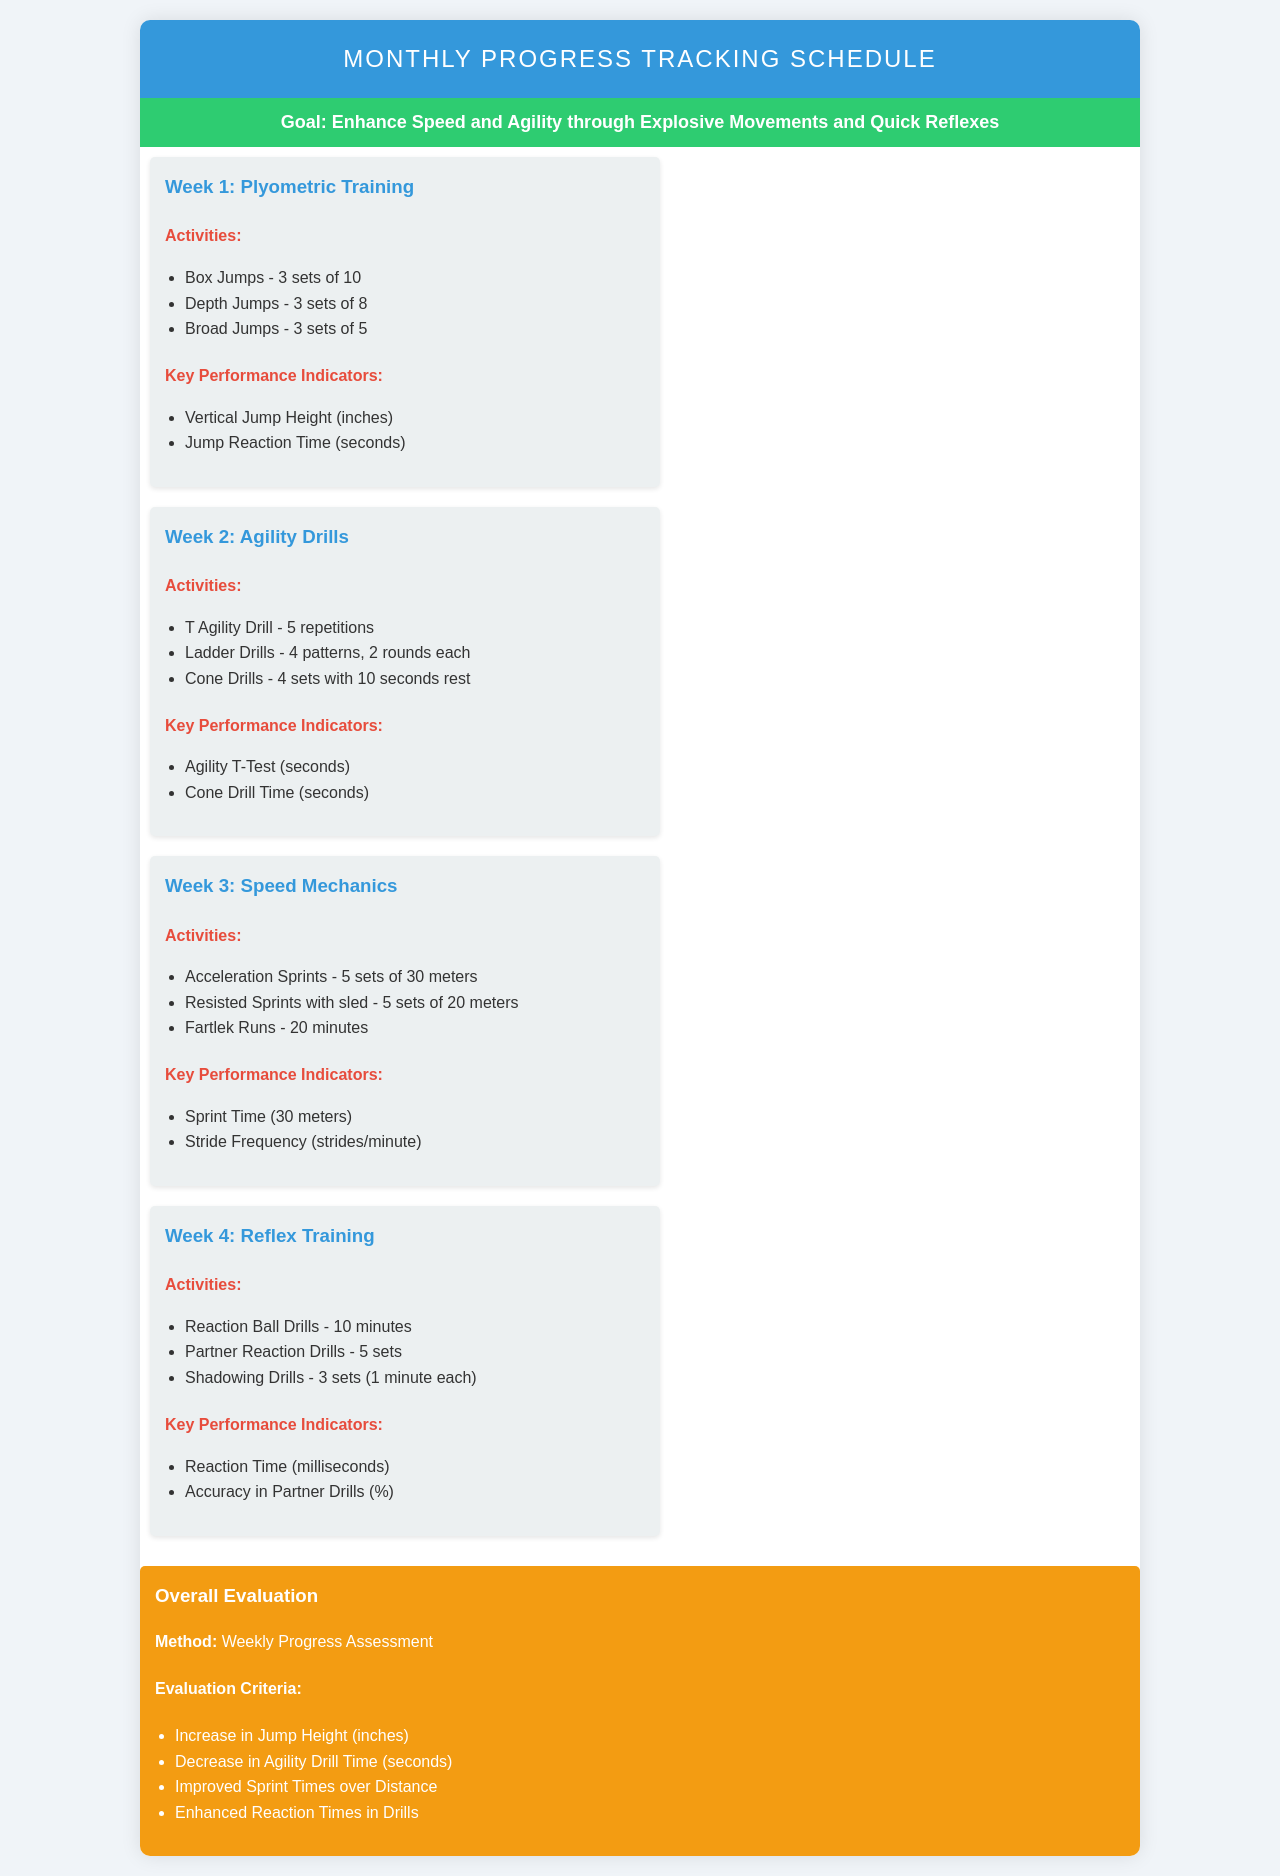What is the goal of the schedule? The goal is to enhance speed and agility through explosive movements and quick reflexes.
Answer: Enhance Speed and Agility through Explosive Movements and Quick Reflexes How many sets of box jumps are prescribed? The document specifies 3 sets of 10 for box jumps in Week 1.
Answer: 3 sets of 10 What is the key performance indicator for Week 2? The key performance indicators for Week 2 include Agility T-Test and Cone Drill Time.
Answer: Agility T-Test (seconds) Which week focuses on reflex training? The schedule explicitly indicates that Week 4 is dedicated to reflex training activities.
Answer: Week 4 How long should the Fartlek Runs last? The duration for Fartlek Runs is specified as 20 minutes in Week 3.
Answer: 20 minutes What is the evaluation criteria for sprint performance? The criteria include improved sprint times over the specified distance as mentioned in the evaluation section.
Answer: Improved Sprint Times over Distance How many repetitions of the T Agility Drill are listed? The document indicates 5 repetitions of the T Agility Drill in Week 2.
Answer: 5 repetitions What is the color code for the goal section? The goal section's background color is specified as green in the document.
Answer: Green What type of assessment method is used for the overall evaluation? The assessment method used is a weekly progress assessment as stated in the evaluation section.
Answer: Weekly Progress Assessment 